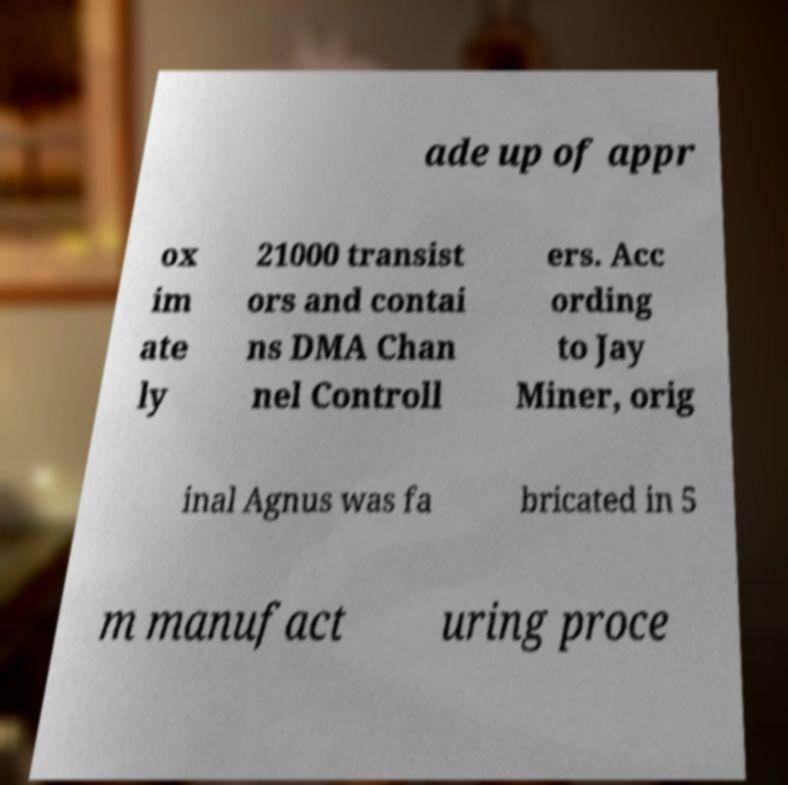Can you accurately transcribe the text from the provided image for me? ade up of appr ox im ate ly 21000 transist ors and contai ns DMA Chan nel Controll ers. Acc ording to Jay Miner, orig inal Agnus was fa bricated in 5 m manufact uring proce 